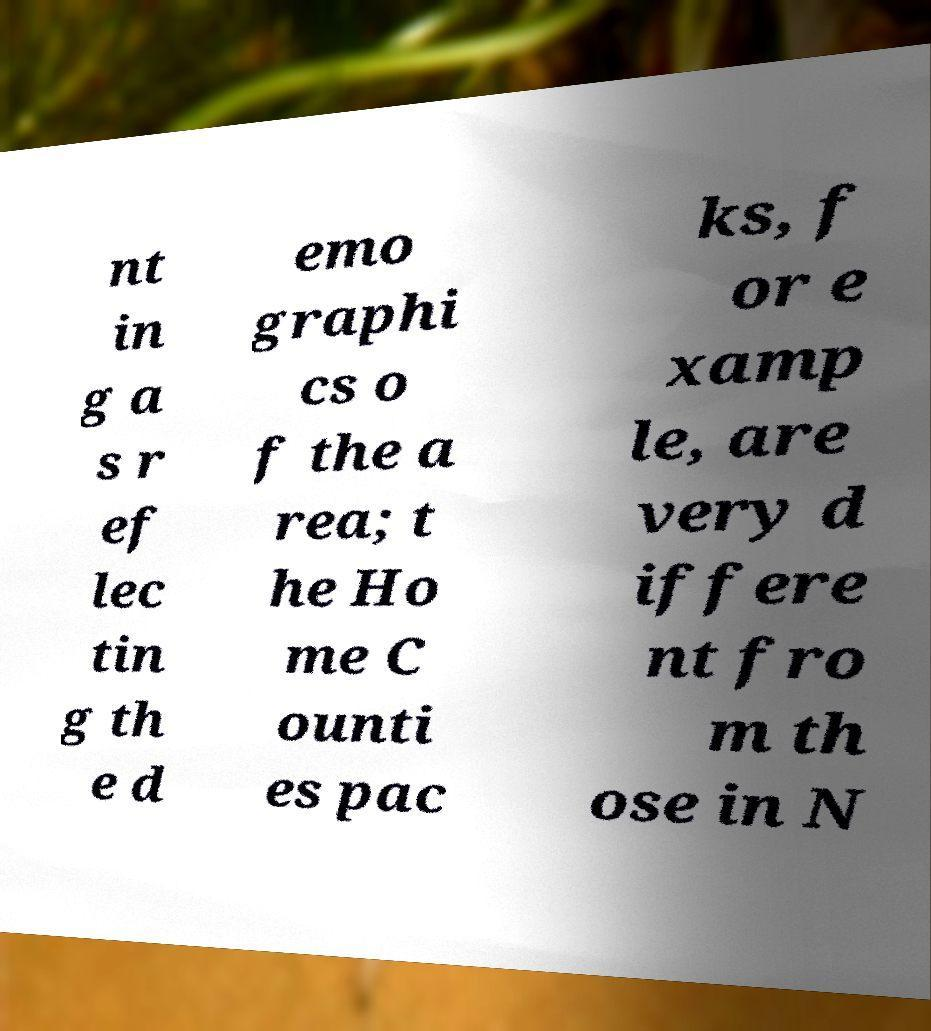Can you accurately transcribe the text from the provided image for me? nt in g a s r ef lec tin g th e d emo graphi cs o f the a rea; t he Ho me C ounti es pac ks, f or e xamp le, are very d iffere nt fro m th ose in N 